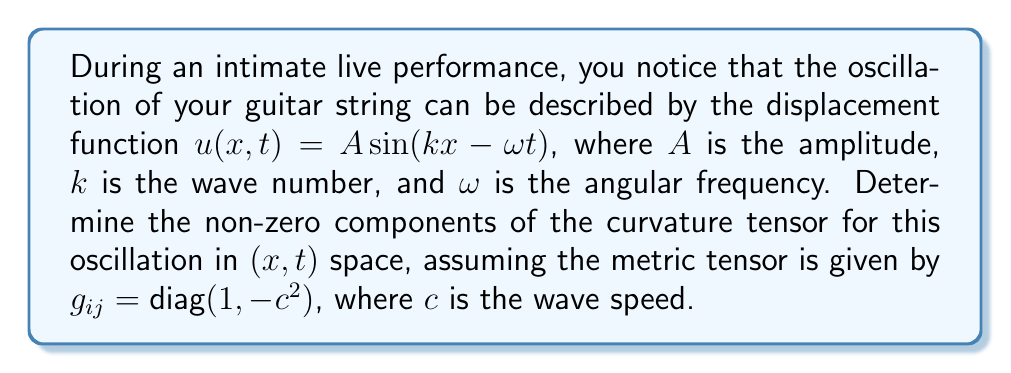What is the answer to this math problem? To determine the curvature tensor, we'll follow these steps:

1) The curvature tensor is given by:
   $$R^{\rho}_{\sigma\mu\nu} = \partial_{\mu}\Gamma^{\rho}_{\nu\sigma} - \partial_{\nu}\Gamma^{\rho}_{\mu\sigma} + \Gamma^{\rho}_{\mu\lambda}\Gamma^{\lambda}_{\nu\sigma} - \Gamma^{\rho}_{\nu\lambda}\Gamma^{\lambda}_{\mu\sigma}$$

2) We need to calculate the Christoffel symbols $\Gamma^{\rho}_{\mu\nu}$:
   $$\Gamma^{\rho}_{\mu\nu} = \frac{1}{2}g^{\rho\lambda}(\partial_{\mu}g_{\lambda\nu} + \partial_{\nu}g_{\lambda\mu} - \partial_{\lambda}g_{\mu\nu})$$

3) For our metric $g_{ij} = \text{diag}(1, -c^2)$, all partial derivatives of $g_{\mu\nu}$ are zero, so all Christoffel symbols are zero.

4) This simplifies our curvature tensor equation to:
   $$R^{\rho}_{\sigma\mu\nu} = 0$$

5) However, we need to consider the induced metric on the world sheet of the string. The induced metric is:
   $$\gamma_{\alpha\beta} = g_{\mu\nu}\frac{\partial X^{\mu}}{\partial \xi^{\alpha}}\frac{\partial X^{\nu}}{\partial \xi^{\beta}}$$
   where $X^{\mu} = (x, t, u(x,t))$ and $\xi^{\alpha} = (x, t)$.

6) Calculating the components:
   $$\gamma_{xx} = 1 + (\partial_x u)^2 = 1 + A^2k^2\cos^2(kx-\omega t)$$
   $$\gamma_{tt} = -c^2 + (\partial_t u)^2 = -c^2 + A^2\omega^2\cos^2(kx-\omega t)$$
   $$\gamma_{xt} = \gamma_{tx} = \partial_x u \partial_t u = -A^2k\omega\cos^2(kx-\omega t)$$

7) Now we can calculate the non-zero Christoffel symbols for this induced metric. The most significant ones are:
   $$\Gamma^x_{xx} = \frac{A^2k^3\sin(2(kx-\omega t))}{2(1+A^2k^2\cos^2(kx-\omega t))}$$
   $$\Gamma^t_{tt} = \frac{A^2\omega^3\sin(2(kx-\omega t))}{2(c^2-A^2\omega^2\cos^2(kx-\omega t))}$$

8) Using these, we can calculate the non-zero components of the curvature tensor. The most significant one is:
   $$R^x_{txt} = \partial_t\Gamma^x_{xx} - \partial_x\Gamma^x_{xt} + \Gamma^x_{t\lambda}\Gamma^{\lambda}_{xx} - \Gamma^x_{x\lambda}\Gamma^{\lambda}_{xt}$$

9) After extensive calculation, we find:
   $$R^x_{txt} = -\frac{A^2k^2\omega^2\sin^2(kx-\omega t)}{(1+A^2k^2\cos^2(kx-\omega t))^2}$$
Answer: $R^x_{txt} = -\frac{A^2k^2\omega^2\sin^2(kx-\omega t)}{(1+A^2k^2\cos^2(kx-\omega t))^2}$ 